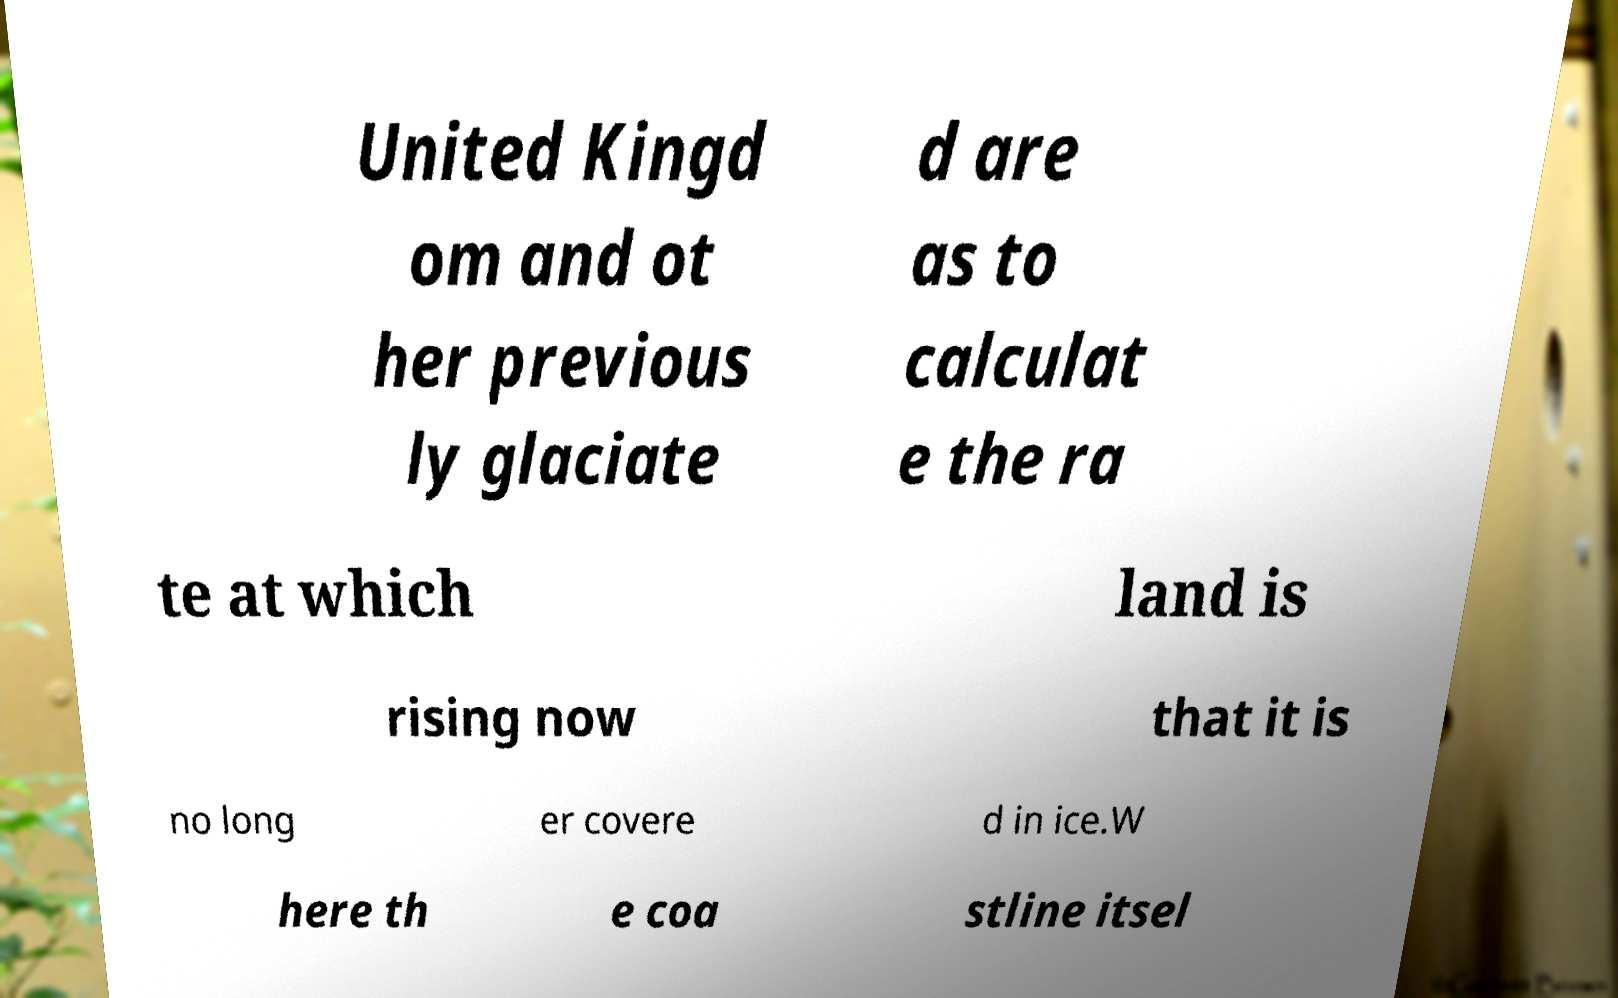For documentation purposes, I need the text within this image transcribed. Could you provide that? United Kingd om and ot her previous ly glaciate d are as to calculat e the ra te at which land is rising now that it is no long er covere d in ice.W here th e coa stline itsel 